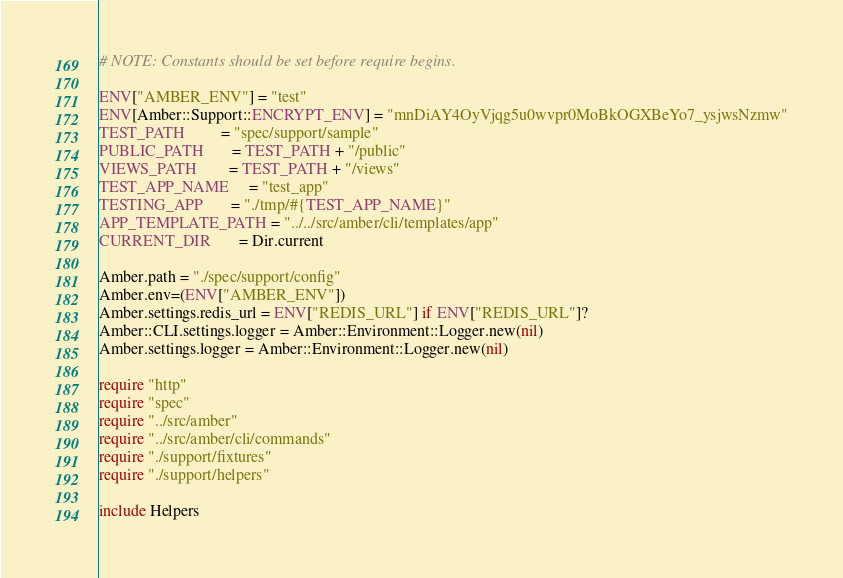<code> <loc_0><loc_0><loc_500><loc_500><_Crystal_># NOTE: Constants should be set before require begins.

ENV["AMBER_ENV"] = "test"
ENV[Amber::Support::ENCRYPT_ENV] = "mnDiAY4OyVjqg5u0wvpr0MoBkOGXBeYo7_ysjwsNzmw"
TEST_PATH         = "spec/support/sample"
PUBLIC_PATH       = TEST_PATH + "/public"
VIEWS_PATH        = TEST_PATH + "/views"
TEST_APP_NAME     = "test_app"
TESTING_APP       = "./tmp/#{TEST_APP_NAME}"
APP_TEMPLATE_PATH = "../../src/amber/cli/templates/app"
CURRENT_DIR       = Dir.current

Amber.path = "./spec/support/config"
Amber.env=(ENV["AMBER_ENV"])
Amber.settings.redis_url = ENV["REDIS_URL"] if ENV["REDIS_URL"]?
Amber::CLI.settings.logger = Amber::Environment::Logger.new(nil)
Amber.settings.logger = Amber::Environment::Logger.new(nil)

require "http"
require "spec"
require "../src/amber"
require "../src/amber/cli/commands"
require "./support/fixtures"
require "./support/helpers"

include Helpers
</code> 